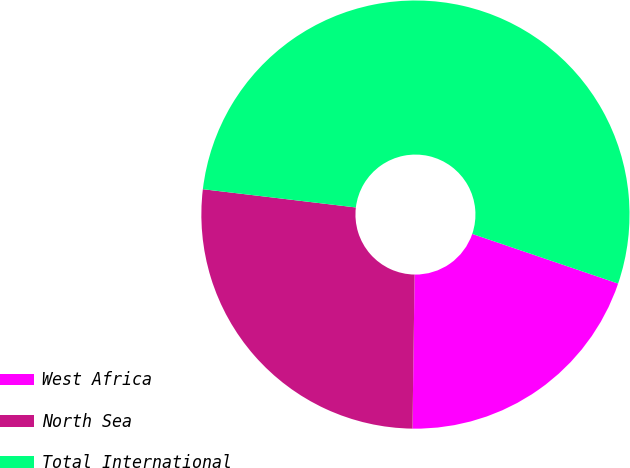Convert chart to OTSL. <chart><loc_0><loc_0><loc_500><loc_500><pie_chart><fcel>West Africa<fcel>North Sea<fcel>Total International<nl><fcel>20.0%<fcel>26.67%<fcel>53.33%<nl></chart> 